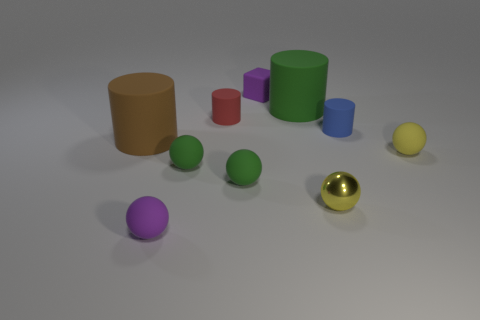There is a brown object; are there any matte cubes left of it?
Your answer should be compact. No. Is the size of the green rubber thing behind the blue cylinder the same as the brown rubber thing that is left of the block?
Offer a terse response. Yes. Is there a cylinder that has the same size as the yellow matte sphere?
Your answer should be very brief. Yes. Is the shape of the purple rubber object that is in front of the small yellow matte thing the same as  the tiny red matte thing?
Keep it short and to the point. No. What is the material of the small cylinder to the left of the metal thing?
Offer a terse response. Rubber. The object that is in front of the shiny object that is behind the small purple rubber sphere is what shape?
Your answer should be very brief. Sphere. There is a tiny shiny object; is its shape the same as the tiny purple object in front of the large green matte thing?
Ensure brevity in your answer.  Yes. There is a large cylinder that is on the left side of the small purple matte sphere; what number of tiny rubber cylinders are in front of it?
Your answer should be very brief. 0. What is the material of the brown object that is the same shape as the big green thing?
Your response must be concise. Rubber. What number of cyan things are either metal spheres or cylinders?
Offer a very short reply. 0. 